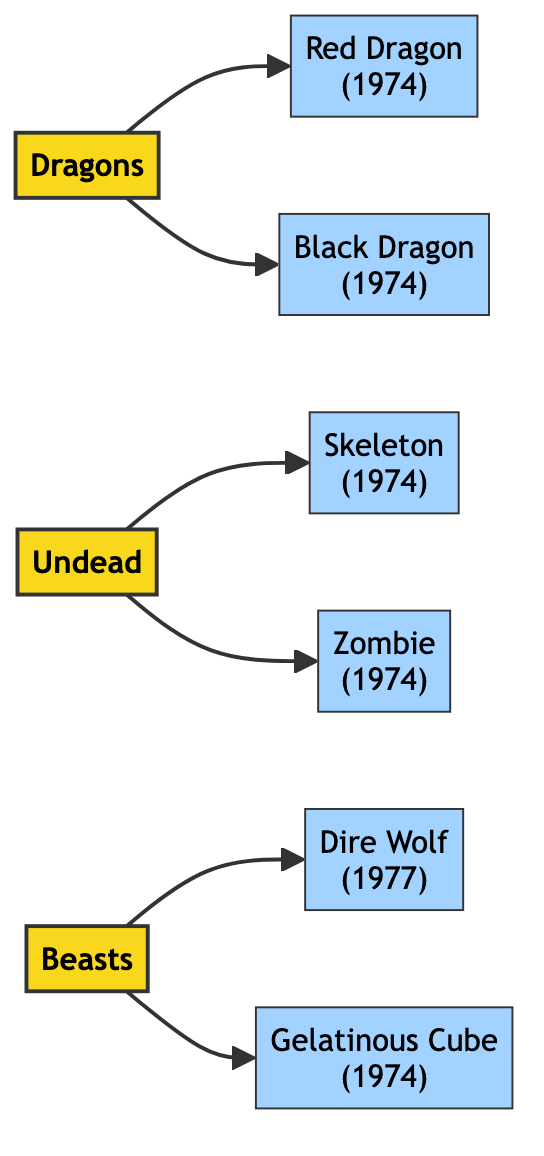What categories are present in the diagram? The diagram includes three categories: Dragons, Undead, and Beasts. These categories are represented as nodes with their respective connections to the specific monsters that fall under them.
Answer: Dragons, Undead, Beasts How many monsters appeared in 1974? According to the diagram, four monsters made their first appearance in 1974: the Red Dragon, Black Dragon, Skeleton, and Zombie. Counting these leads to the answer.
Answer: 4 Which monster belongs to the "Undead" category? The diagram connects the Undead category to two monsters: Skeleton and Zombie. The question can be answered by simply naming one of them.
Answer: Skeleton How many edges are in the diagram? By counting the edges that connect the nodes, there are a total of six edges shown in the diagram. Each edge represents a direct relationship between a category and its monsters.
Answer: 6 What is the first appearance year of the Dire Wolf? The diagram specifies that the Dire Wolf made its first appearance in 1977, indicated next to the monster's name within the node.
Answer: 1977 Which category has the most monsters associated with it? The diagram shows that the Dragons category has two associated monsters (Red Dragon and Black Dragon), whereas both the Undead and Beasts categories also have two monsters. However, the question aims for a specific answer.
Answer: Dragons What type of node is the Gelatinous Cube? The Gelatinous Cube is categorized as a Monster in the diagram. This can be inferred from its representation, distinct from the category nodes.
Answer: Monster Which category connects to a monster first appeared in 1977? The Beasts category connects to the Dire Wolf, which first appeared in 1977. The relationship is clear from the edges pointing from the category to the monster node.
Answer: Beasts 